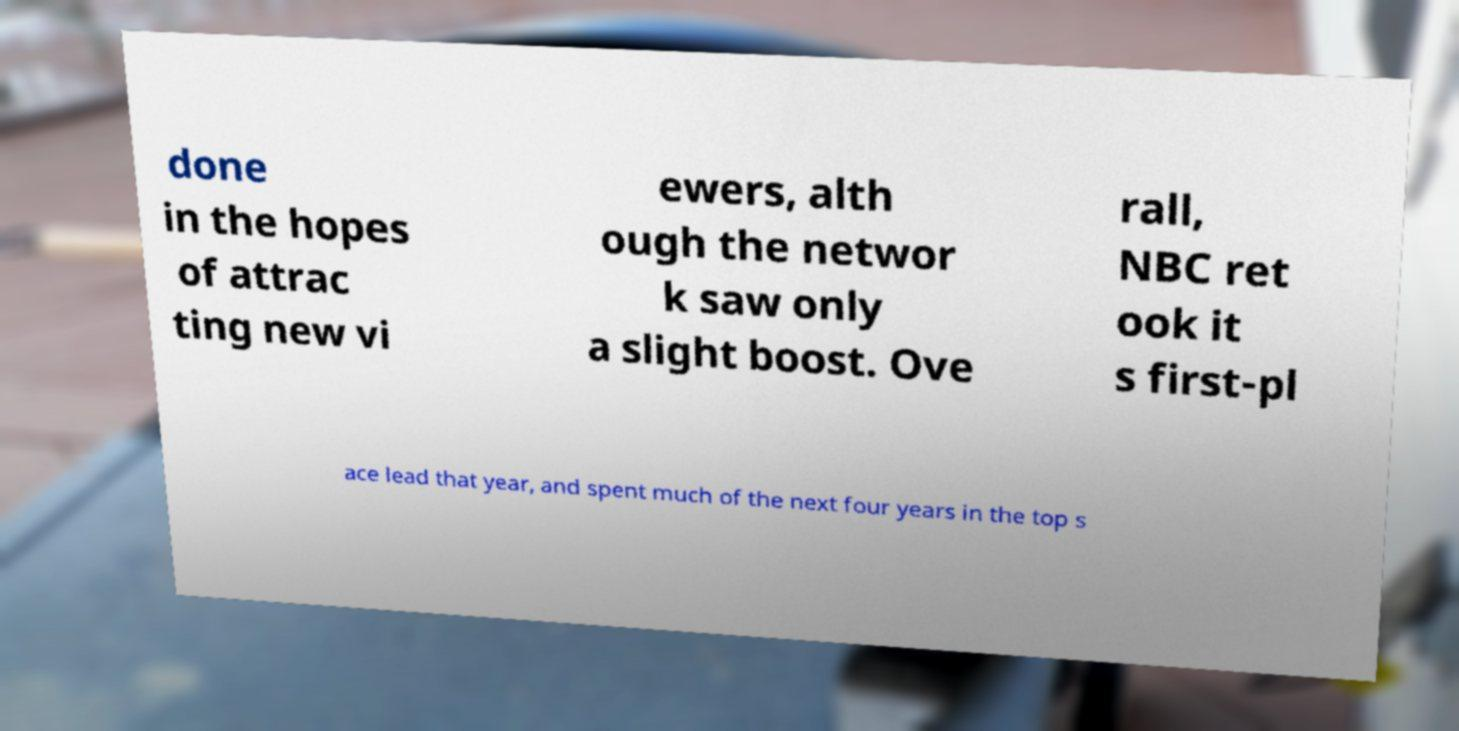There's text embedded in this image that I need extracted. Can you transcribe it verbatim? done in the hopes of attrac ting new vi ewers, alth ough the networ k saw only a slight boost. Ove rall, NBC ret ook it s first-pl ace lead that year, and spent much of the next four years in the top s 